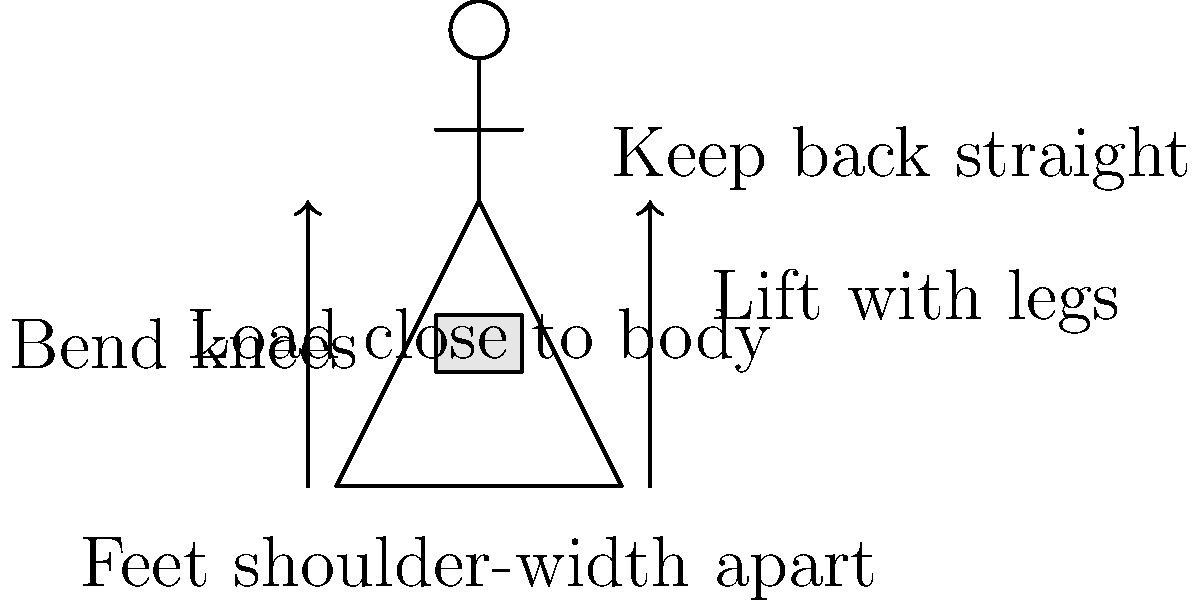In the diagram illustrating proper lifting technique, which biomechanical principle is most crucial for reducing the risk of back injury and ensuring long-term financial stability by preventing workplace accidents? To answer this question, let's analyze the key biomechanical principles illustrated in the diagram:

1. Feet shoulder-width apart: This provides a stable base of support, reducing the risk of losing balance.

2. Bending the knees: This allows the strong leg muscles to bear the load, reducing strain on the back.

3. Keeping the back straight: This maintains the natural curve of the spine, minimizing the risk of disc herniation or other back injuries.

4. Keeping the load close to the body: This reduces the moment arm, decreasing the torque on the spine and the effort required to lift.

5. Lifting with the legs: This principle combines bending the knees and keeping the back straight, utilizing the powerful leg muscles instead of relying on the more vulnerable back muscles.

Among these principles, lifting with the legs is the most crucial for reducing the risk of back injury. This technique distributes the load more evenly across the body's strongest muscle groups (quadriceps and gluteal muscles) while minimizing stress on the spine.

For a parent worried about their child's financial stability, understanding this principle is vital. Proper lifting technique can prevent workplace injuries that might lead to medical expenses, lost wages, or even long-term disability, all of which could significantly impact a person's financial well-being and ability to repay student loans.
Answer: Lifting with the legs 